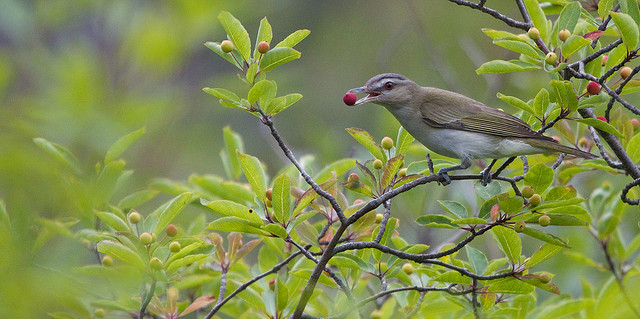<image>Is this a female bird? I'm not sure if this is a female bird, but the majority guess is yes. Is this a female bird? I don't know if this is a female bird. It can be both male and female. 